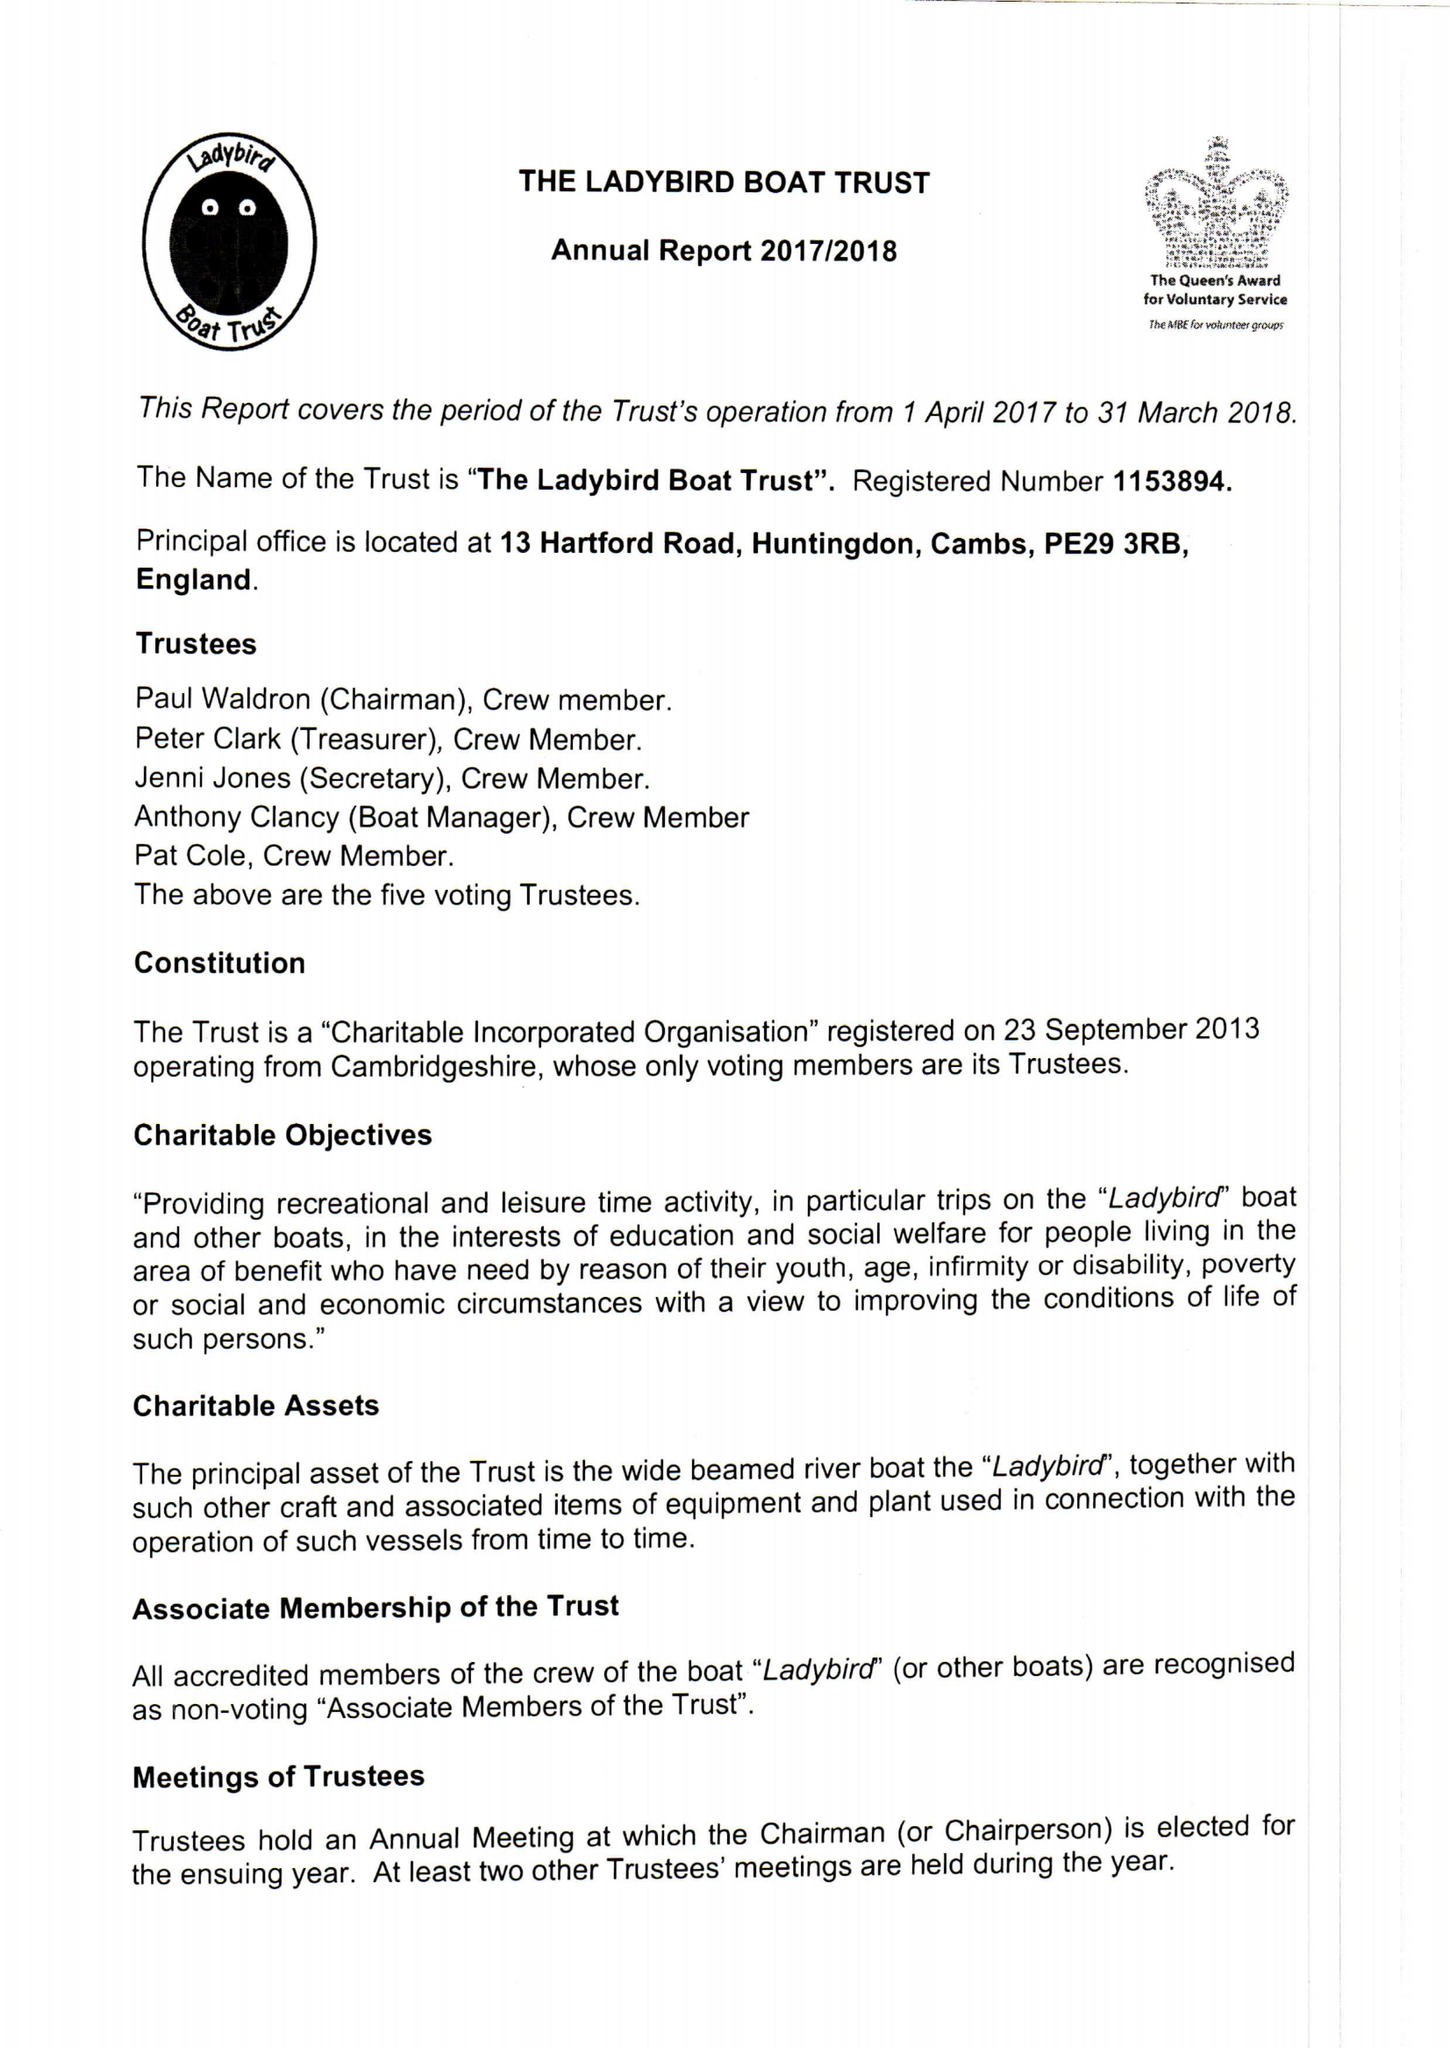What is the value for the address__post_town?
Answer the question using a single word or phrase. HUNTINGDON 